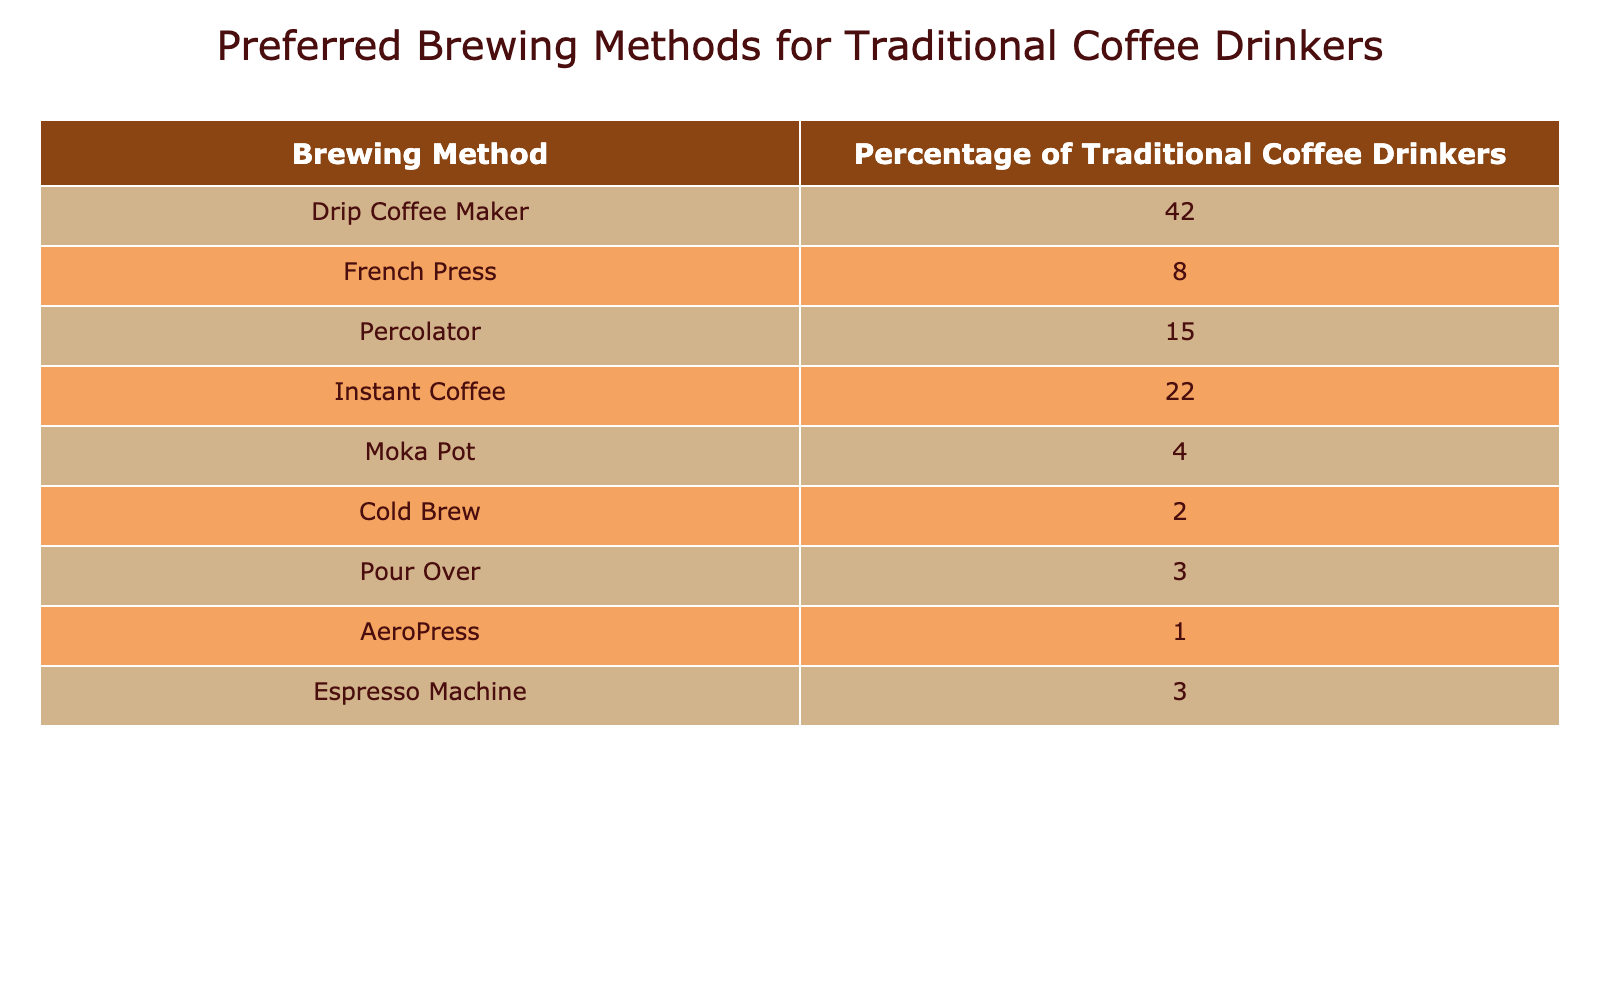What is the percentage of traditional coffee drinkers that prefer drip coffee makers? The table shows that the percentage of traditional coffee drinkers that prefer drip coffee makers is directly listed under the corresponding brewing method. It indicates a value of 42.
Answer: 42 Which brewing method has the lowest percentage among traditional coffee drinkers? By examining the table, we can see the brewing methods listed along with their percentages. The lowest percentage is for AeroPress, which is 1%.
Answer: 1% What is the combined percentage of traditional coffee drinkers who prefer instant coffee and percolators? To find the combined percentage, we add the percentages for instant coffee (22%) and percolators (15%). The calculation is 22 + 15 = 37.
Answer: 37 Is there a higher preference for using the Moka Pot or pour-over among traditional coffee drinkers? The percentages for the Moka Pot (4%) and pour-over (3%) are compared directly from the table. Since 4% is greater than 3%, the Moka Pot has a higher preference.
Answer: Yes What is the total percentage of traditional coffee drinkers who prefer methods other than drip coffee makers? To find this total, we first take the percentage for drip coffee makers (42%) and subtract it from 100% to account for the rest. The calculation is 100 - 42 = 58.
Answer: 58 How many brewing methods have a percentage of 5% or less among traditional coffee drinkers? We can look through the table and count the brewing methods with a percentage of 5% or less: Cold Brew (2%), AeroPress (1%), and pour-over (3%). This makes a total of 3 methods.
Answer: 3 What is the difference in percentage between the most and least preferred brewing methods by traditional coffee drinkers? The most preferred method is drip coffee makers at 42% and the least preferred is AeroPress at 1%. The difference is calculated as 42 - 1 = 41.
Answer: 41 Which brewing method is preferred by more than 20% of traditional coffee drinkers? By examining the table, we look for percentages above 20%. The only brewing method that meets this criterion is the drip coffee maker (42%) and instant coffee (22%).
Answer: Drip coffee maker and instant coffee What is the average percentage of traditional coffee drinkers for all brewing methods listed in the table? The total percentage for all methods is calculated by summing all the values: 42 + 8 + 15 + 22 + 4 + 2 + 3 + 1 + 3 = 100. Divided by the number of methods (9), the average is 100 / 9 ≈ 11.11.
Answer: 11.11 Is the preference for cold brew greater than that for espresso machines? The table shows that the percentage for cold brew is 2% and for espresso machines is 3%. Since 2% is less than 3%, cold brew is not preferred over espresso machines.
Answer: No 